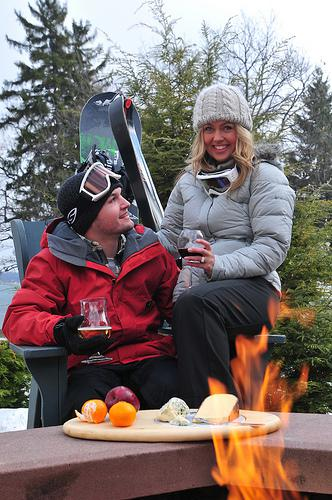Question: what color is the man's jacket?
Choices:
A. Black.
B. White.
C. Green.
D. Red.
Answer with the letter. Answer: D Question: where are the woman's goggles?
Choices:
A. In her hand.
B. On her head.
C. Around her neck.
D. Over her eyes.
Answer with the letter. Answer: C Question: what is the woman drinking?
Choices:
A. Water.
B. Soda.
C. Beer.
D. Wine.
Answer with the letter. Answer: D Question: how many oranges are there?
Choices:
A. Two.
B. Three.
C. Four.
D. Five.
Answer with the letter. Answer: A 